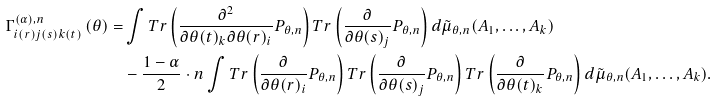Convert formula to latex. <formula><loc_0><loc_0><loc_500><loc_500>\Gamma _ { i ( r ) j ( s ) k ( t ) } ^ { ( \alpha ) , n } \left ( \theta \right ) = & \int T r \left ( \frac { \partial ^ { 2 } } { \partial \theta ( t ) _ { k } \partial \theta ( r ) _ { i } } P _ { \theta , n } \right ) T r \left ( \frac { \partial } { \partial \theta ( s ) _ { j } } P _ { \theta , n } \right ) d \tilde { \mu } _ { \theta , n } ( A _ { 1 } , \dots , A _ { k } ) \\ & - \frac { 1 - \alpha } { 2 } \cdot { n } \int T r \left ( \frac { \partial } { \partial \theta ( r ) _ { i } } P _ { \theta , n } \right ) T r \left ( \frac { \partial } { \partial \theta ( s ) _ { j } } P _ { \theta , n } \right ) T r \left ( \frac { \partial } { \partial \theta ( t ) _ { k } } P _ { \theta , n } \right ) d \tilde { \mu } _ { \theta , n } ( A _ { 1 } , \dots , A _ { k } ) .</formula> 